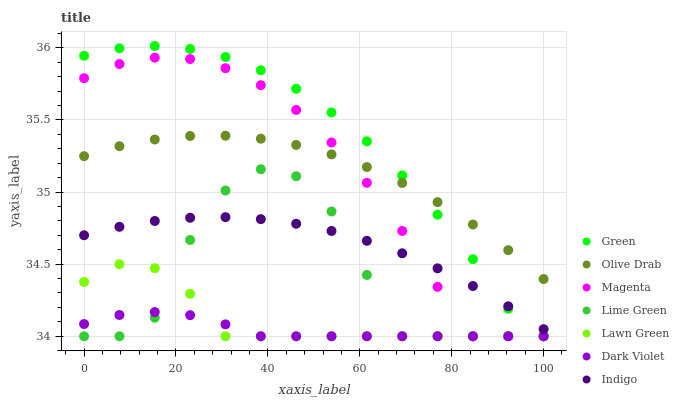Does Dark Violet have the minimum area under the curve?
Answer yes or no. Yes. Does Green have the maximum area under the curve?
Answer yes or no. Yes. Does Indigo have the minimum area under the curve?
Answer yes or no. No. Does Indigo have the maximum area under the curve?
Answer yes or no. No. Is Indigo the smoothest?
Answer yes or no. Yes. Is Lime Green the roughest?
Answer yes or no. Yes. Is Dark Violet the smoothest?
Answer yes or no. No. Is Dark Violet the roughest?
Answer yes or no. No. Does Lawn Green have the lowest value?
Answer yes or no. Yes. Does Indigo have the lowest value?
Answer yes or no. No. Does Green have the highest value?
Answer yes or no. Yes. Does Indigo have the highest value?
Answer yes or no. No. Is Lawn Green less than Indigo?
Answer yes or no. Yes. Is Indigo greater than Lawn Green?
Answer yes or no. Yes. Does Magenta intersect Olive Drab?
Answer yes or no. Yes. Is Magenta less than Olive Drab?
Answer yes or no. No. Is Magenta greater than Olive Drab?
Answer yes or no. No. Does Lawn Green intersect Indigo?
Answer yes or no. No. 